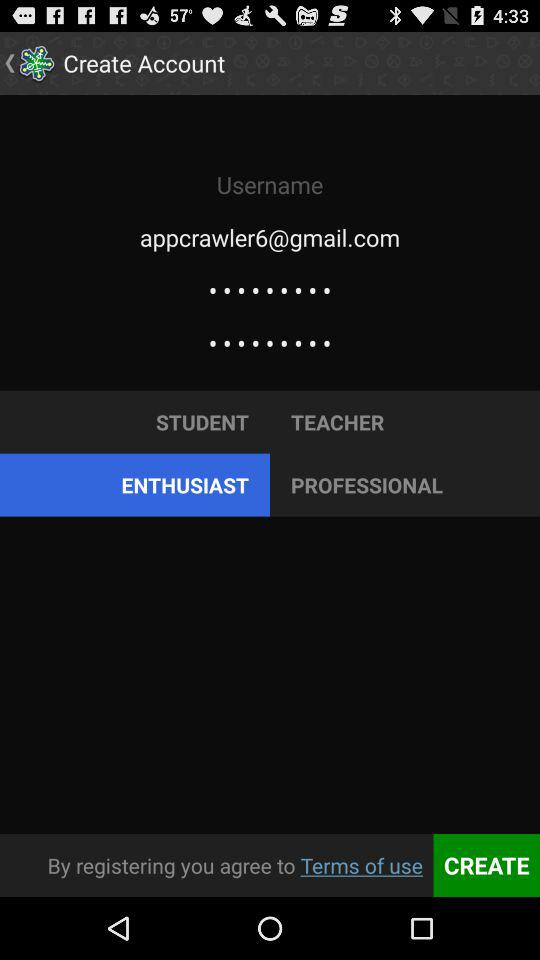What is the email address? The email address is appcrawler6@gmail.com. 